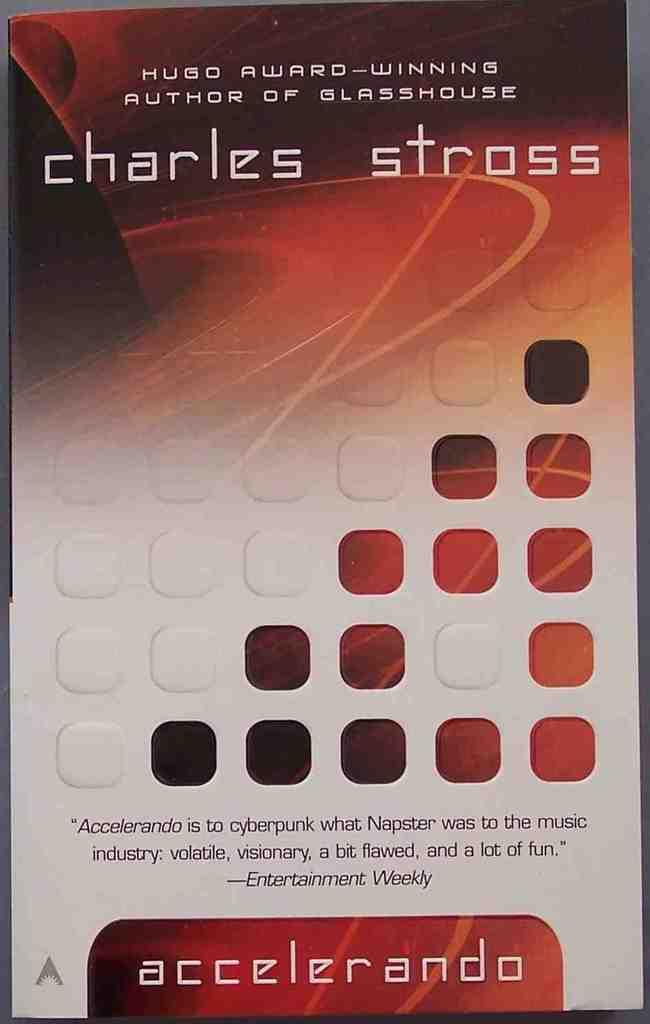Provide a one-sentence caption for the provided image. The book jacket says that Charles Stross won a Hugo award. 